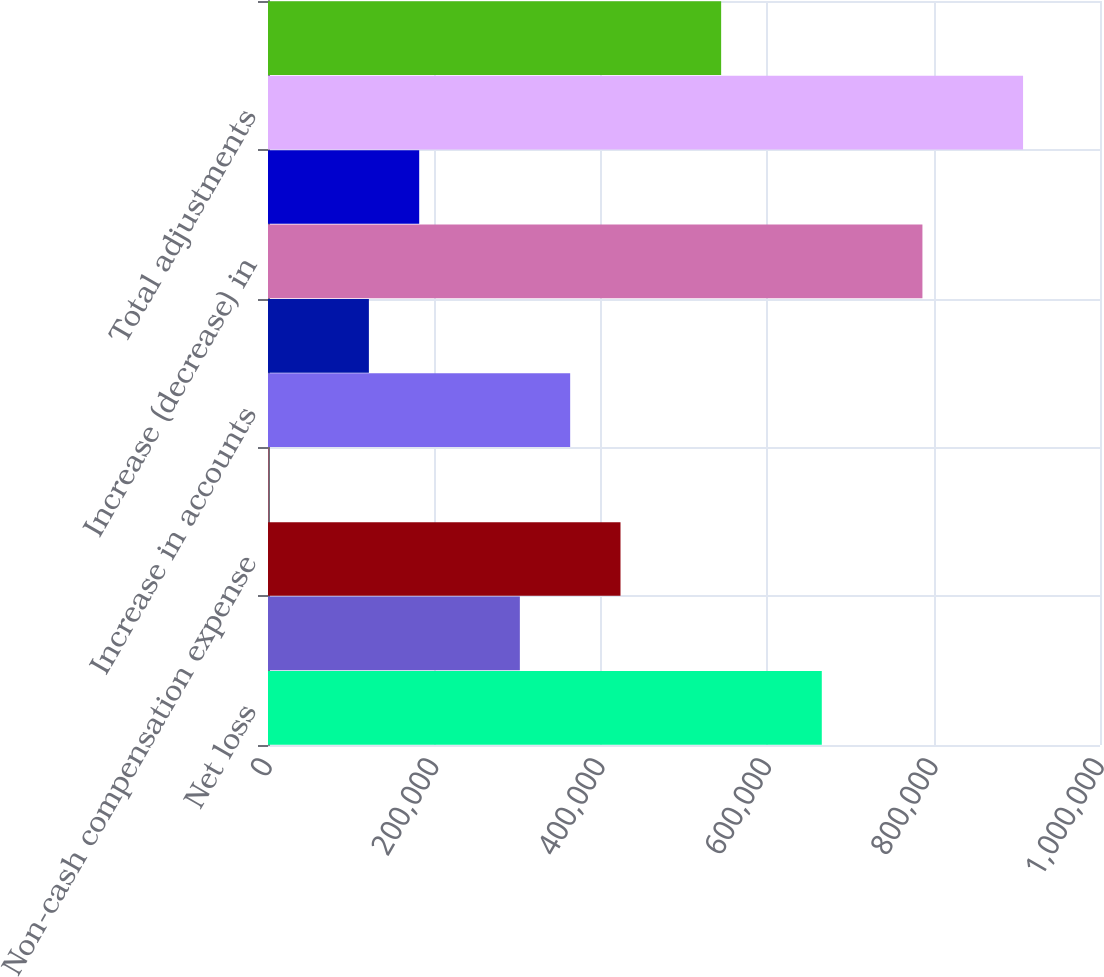Convert chart to OTSL. <chart><loc_0><loc_0><loc_500><loc_500><bar_chart><fcel>Net loss<fcel>Depreciation and amortization<fcel>Non-cash compensation expense<fcel>Net realized loss (gain) on<fcel>Increase in accounts<fcel>Decrease (increase) in prepaid<fcel>Increase (decrease) in<fcel>and other liabilities<fcel>Total adjustments<fcel>Net cash provided by (used in)<nl><fcel>665607<fcel>302708<fcel>423675<fcel>293<fcel>363192<fcel>121259<fcel>786573<fcel>181742<fcel>907540<fcel>544641<nl></chart> 